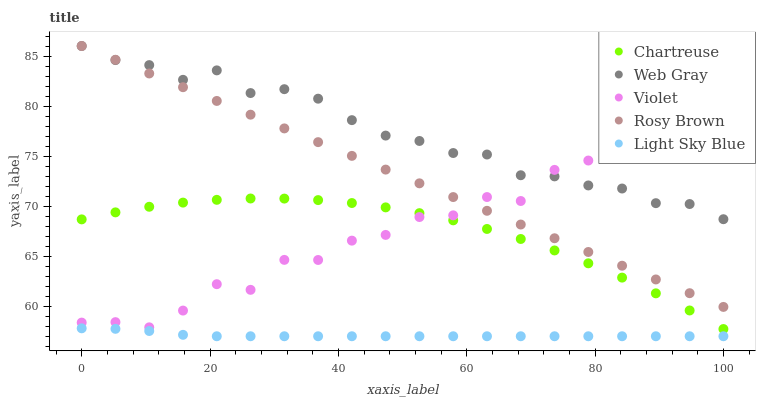Does Light Sky Blue have the minimum area under the curve?
Answer yes or no. Yes. Does Web Gray have the maximum area under the curve?
Answer yes or no. Yes. Does Chartreuse have the minimum area under the curve?
Answer yes or no. No. Does Chartreuse have the maximum area under the curve?
Answer yes or no. No. Is Rosy Brown the smoothest?
Answer yes or no. Yes. Is Violet the roughest?
Answer yes or no. Yes. Is Chartreuse the smoothest?
Answer yes or no. No. Is Chartreuse the roughest?
Answer yes or no. No. Does Light Sky Blue have the lowest value?
Answer yes or no. Yes. Does Chartreuse have the lowest value?
Answer yes or no. No. Does Rosy Brown have the highest value?
Answer yes or no. Yes. Does Chartreuse have the highest value?
Answer yes or no. No. Is Light Sky Blue less than Chartreuse?
Answer yes or no. Yes. Is Rosy Brown greater than Light Sky Blue?
Answer yes or no. Yes. Does Chartreuse intersect Violet?
Answer yes or no. Yes. Is Chartreuse less than Violet?
Answer yes or no. No. Is Chartreuse greater than Violet?
Answer yes or no. No. Does Light Sky Blue intersect Chartreuse?
Answer yes or no. No. 